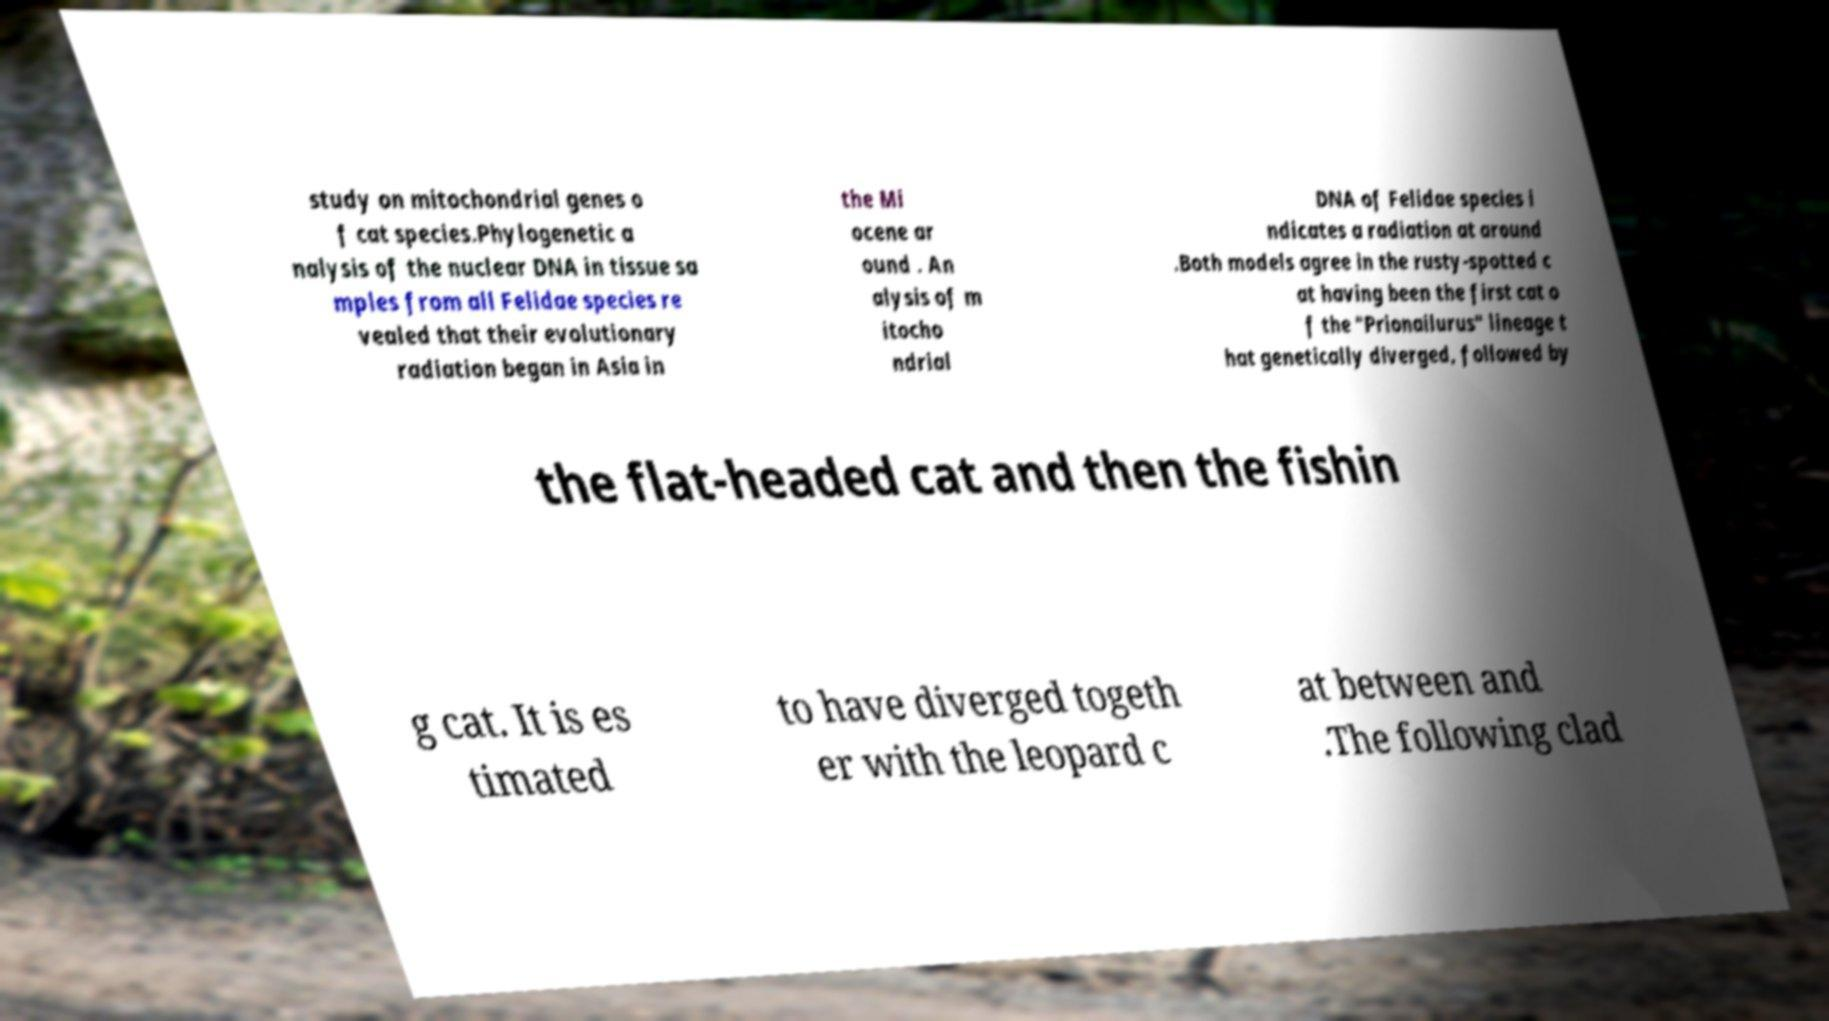There's text embedded in this image that I need extracted. Can you transcribe it verbatim? study on mitochondrial genes o f cat species.Phylogenetic a nalysis of the nuclear DNA in tissue sa mples from all Felidae species re vealed that their evolutionary radiation began in Asia in the Mi ocene ar ound . An alysis of m itocho ndrial DNA of Felidae species i ndicates a radiation at around .Both models agree in the rusty-spotted c at having been the first cat o f the "Prionailurus" lineage t hat genetically diverged, followed by the flat-headed cat and then the fishin g cat. It is es timated to have diverged togeth er with the leopard c at between and .The following clad 